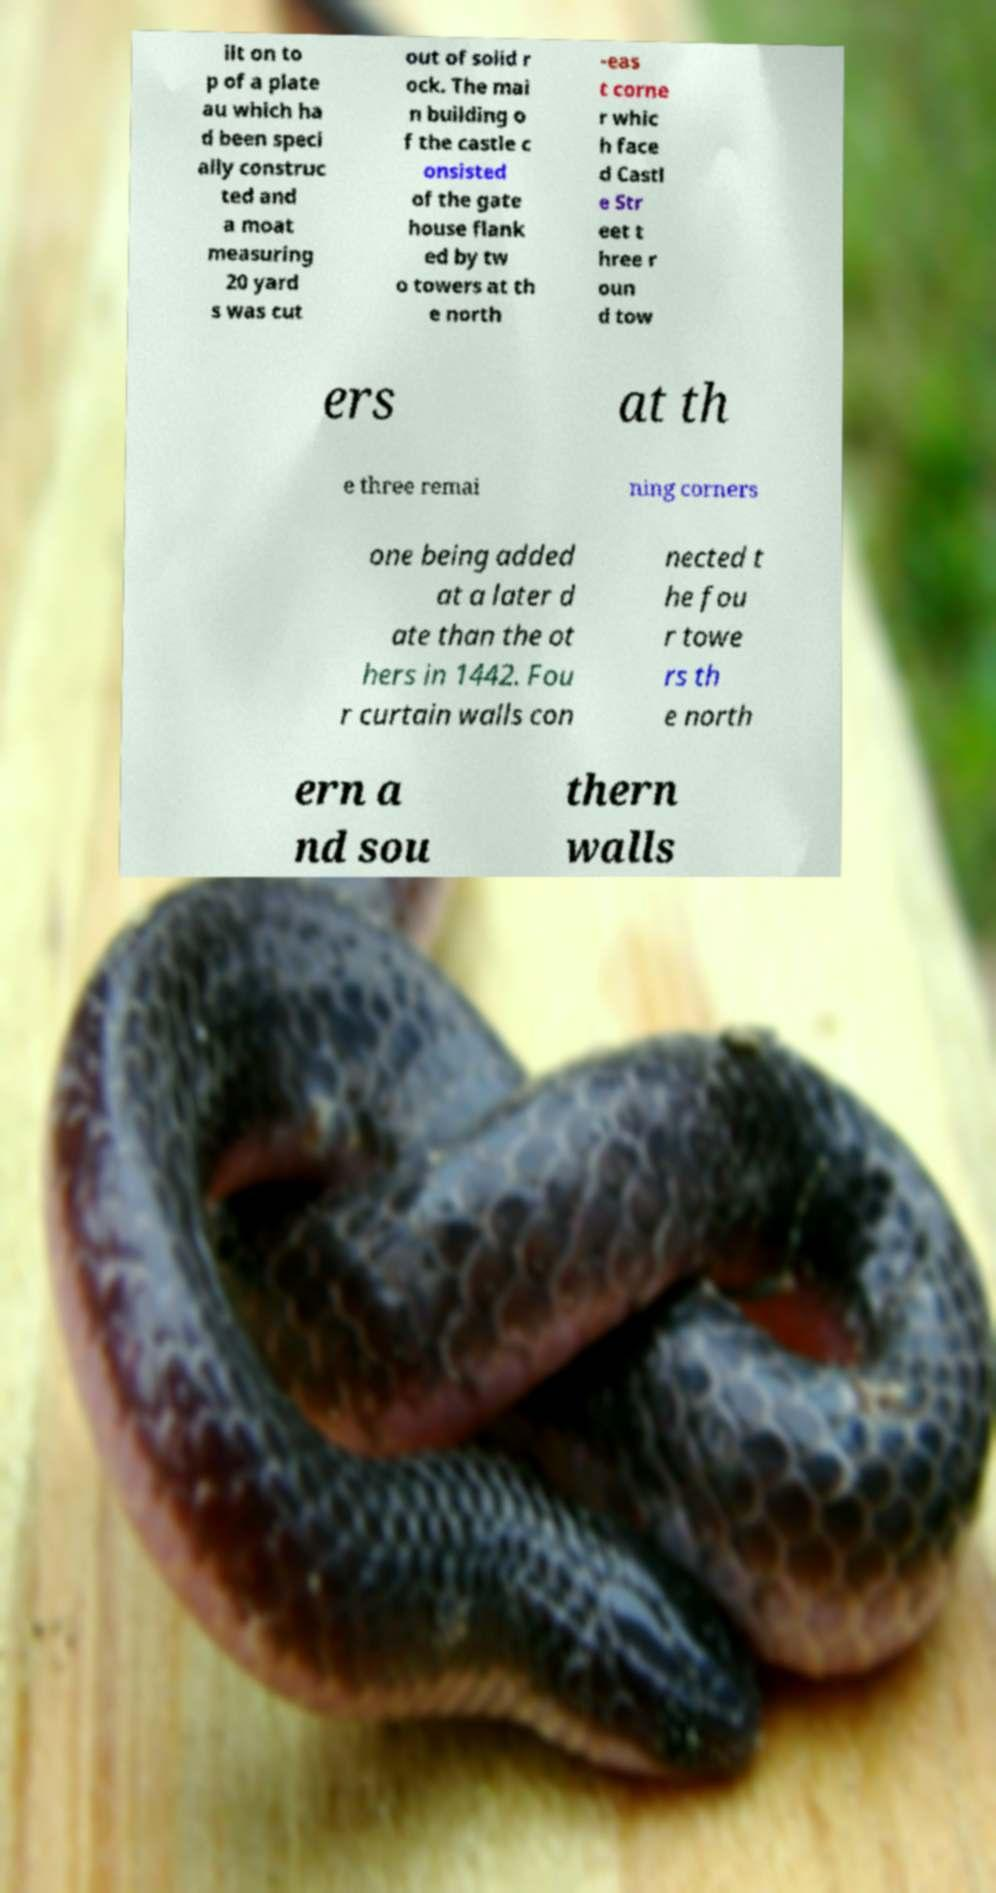Can you read and provide the text displayed in the image?This photo seems to have some interesting text. Can you extract and type it out for me? ilt on to p of a plate au which ha d been speci ally construc ted and a moat measuring 20 yard s was cut out of solid r ock. The mai n building o f the castle c onsisted of the gate house flank ed by tw o towers at th e north -eas t corne r whic h face d Castl e Str eet t hree r oun d tow ers at th e three remai ning corners one being added at a later d ate than the ot hers in 1442. Fou r curtain walls con nected t he fou r towe rs th e north ern a nd sou thern walls 